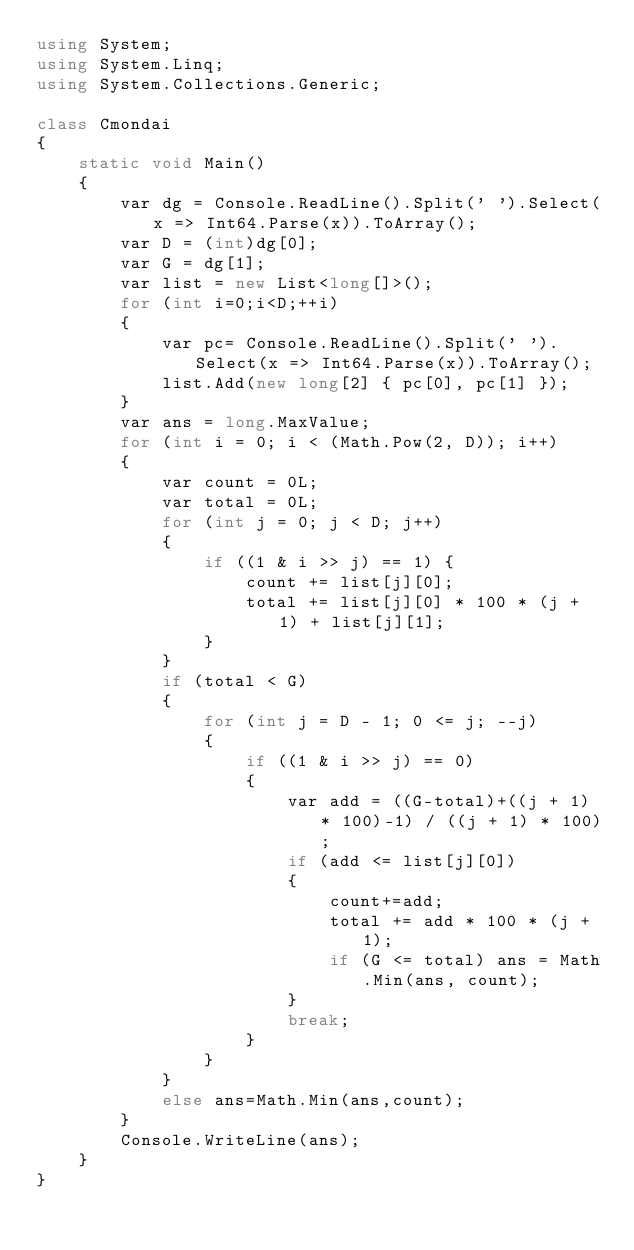Convert code to text. <code><loc_0><loc_0><loc_500><loc_500><_C#_>using System;
using System.Linq;
using System.Collections.Generic;

class Cmondai
{
    static void Main()
    {
        var dg = Console.ReadLine().Split(' ').Select(x => Int64.Parse(x)).ToArray();
        var D = (int)dg[0];
        var G = dg[1];
        var list = new List<long[]>();
        for (int i=0;i<D;++i)
        {
            var pc= Console.ReadLine().Split(' ').Select(x => Int64.Parse(x)).ToArray();
            list.Add(new long[2] { pc[0], pc[1] });
        }
        var ans = long.MaxValue;
        for (int i = 0; i < (Math.Pow(2, D)); i++)
        {
            var count = 0L;
            var total = 0L;
            for (int j = 0; j < D; j++)
            {
                if ((1 & i >> j) == 1) {
                    count += list[j][0];
                    total += list[j][0] * 100 * (j + 1) + list[j][1];
                }
            }
            if (total < G)
            {
                for (int j = D - 1; 0 <= j; --j)
                {
                    if ((1 & i >> j) == 0)
                    {
                        var add = ((G-total)+((j + 1) * 100)-1) / ((j + 1) * 100);
                        if (add <= list[j][0])
                        {
                            count+=add;
                            total += add * 100 * (j + 1);
                            if (G <= total) ans = Math.Min(ans, count);
                        }
                        break;
                    }
                }
            }
            else ans=Math.Min(ans,count);
        }
        Console.WriteLine(ans);
    }
}
</code> 